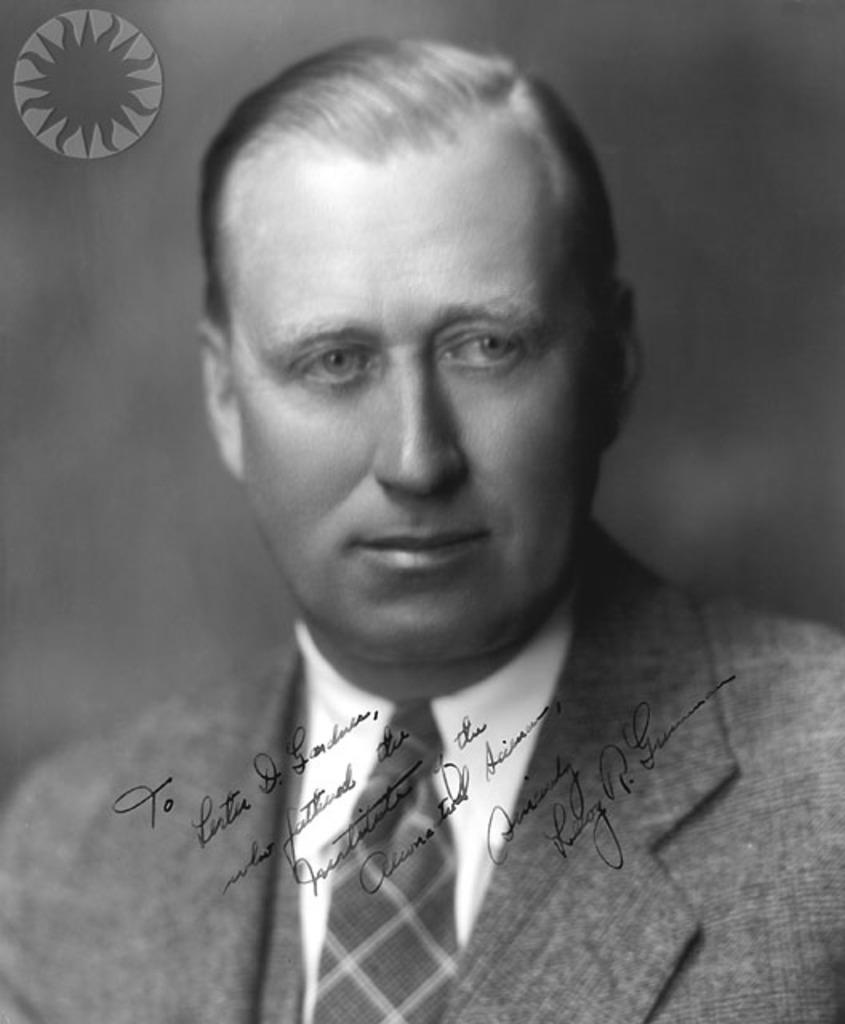Can you describe this image briefly? In the image in the center, we can see one person and we can see something written on it. On the top left of the image, there is a watermark. 